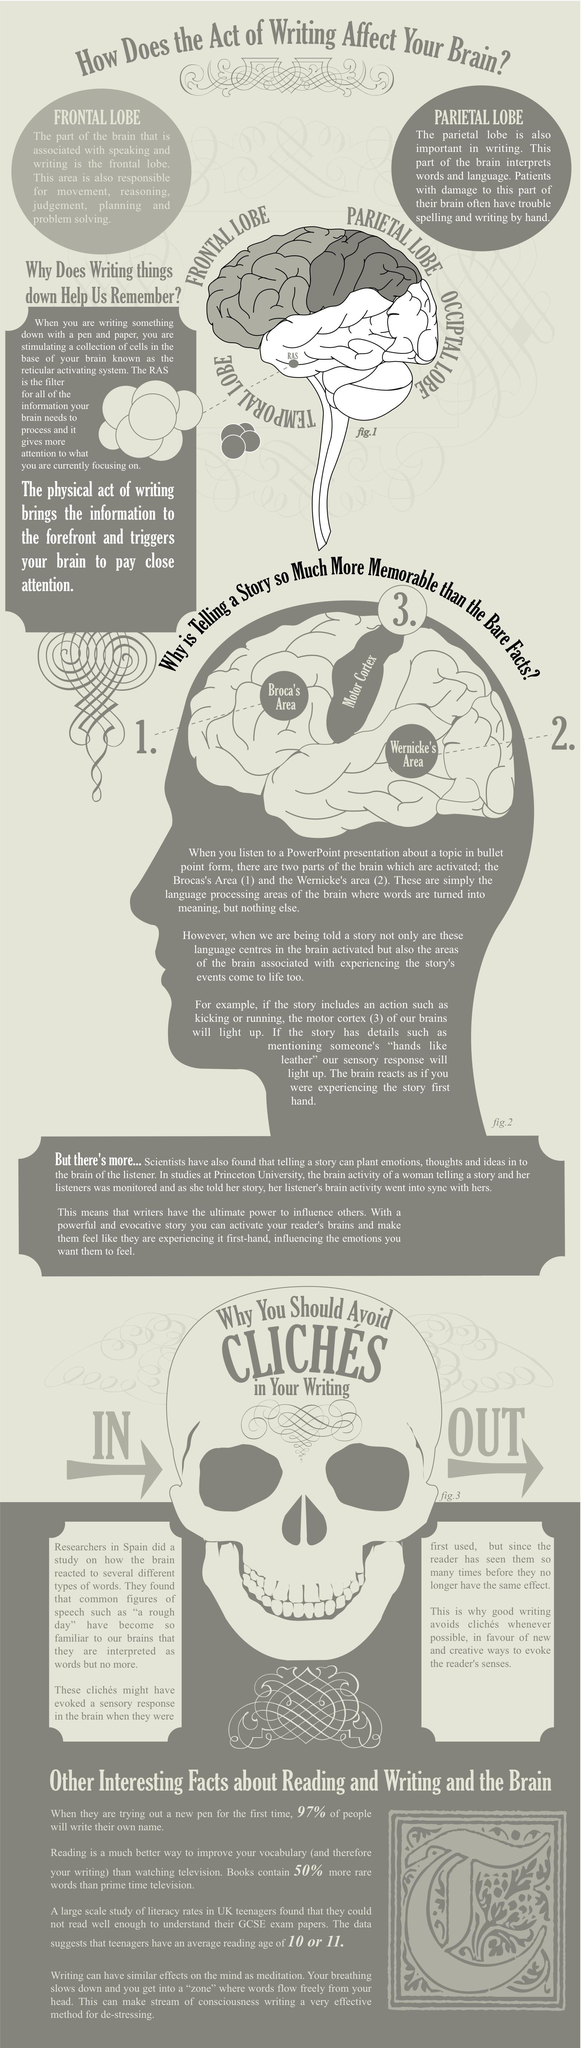Draw attention to some important aspects in this diagram. There are four different types of lobes mentioned. The forehead of the skull contains a mention that should be avoided in writing, and it is important to avoid cliches in order to improve the quality of your writing. RAS is located in the temporal lobe. The occipital lobe is typically depicted in color as being white. The frontal lobe is associated with problem-solving abilities. 